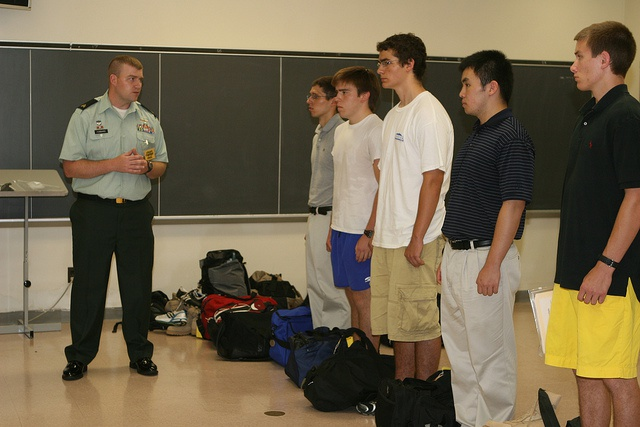Describe the objects in this image and their specific colors. I can see people in black, brown, and gold tones, people in black, darkgray, and gray tones, people in black, darkgray, gray, and brown tones, people in black, tan, lightgray, and gray tones, and people in black, tan, navy, and gray tones in this image. 